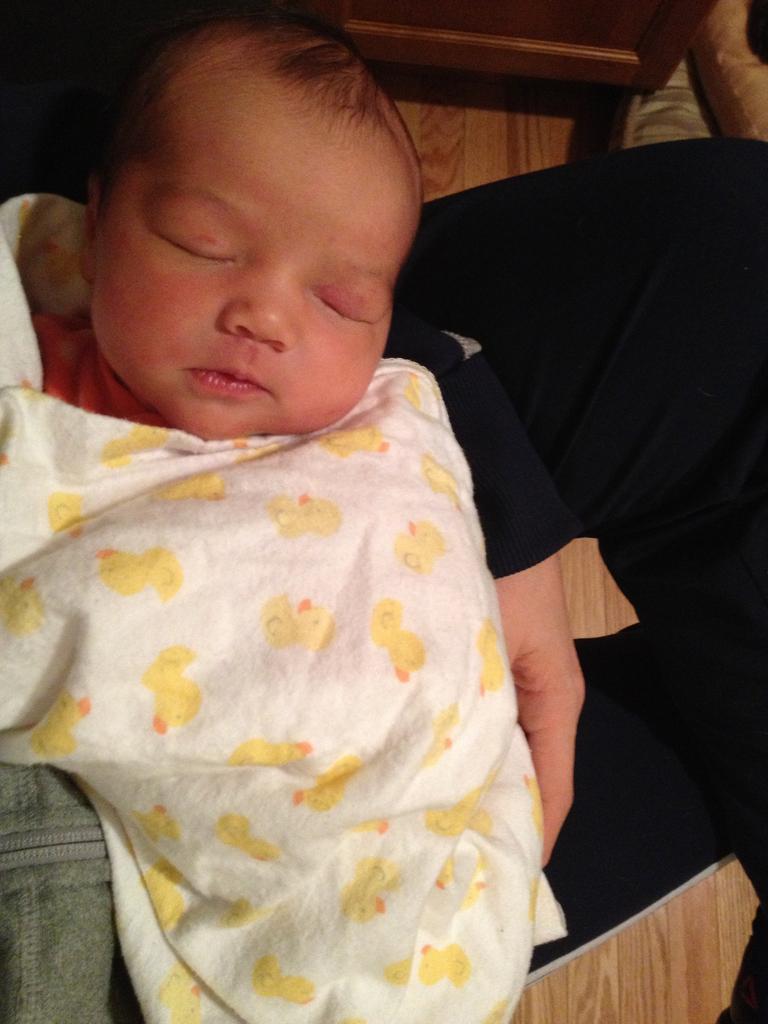Describe this image in one or two sentences. In this image there is a baby sleeping on the bed. There is a blanket covered on the baby. 